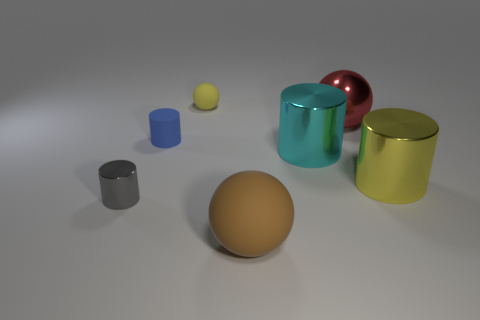Subtract 1 cylinders. How many cylinders are left? 3 Add 2 brown rubber spheres. How many objects exist? 9 Subtract all cylinders. How many objects are left? 3 Add 7 small gray objects. How many small gray objects are left? 8 Add 2 big green rubber cylinders. How many big green rubber cylinders exist? 2 Subtract 0 purple cylinders. How many objects are left? 7 Subtract all red things. Subtract all small gray shiny blocks. How many objects are left? 6 